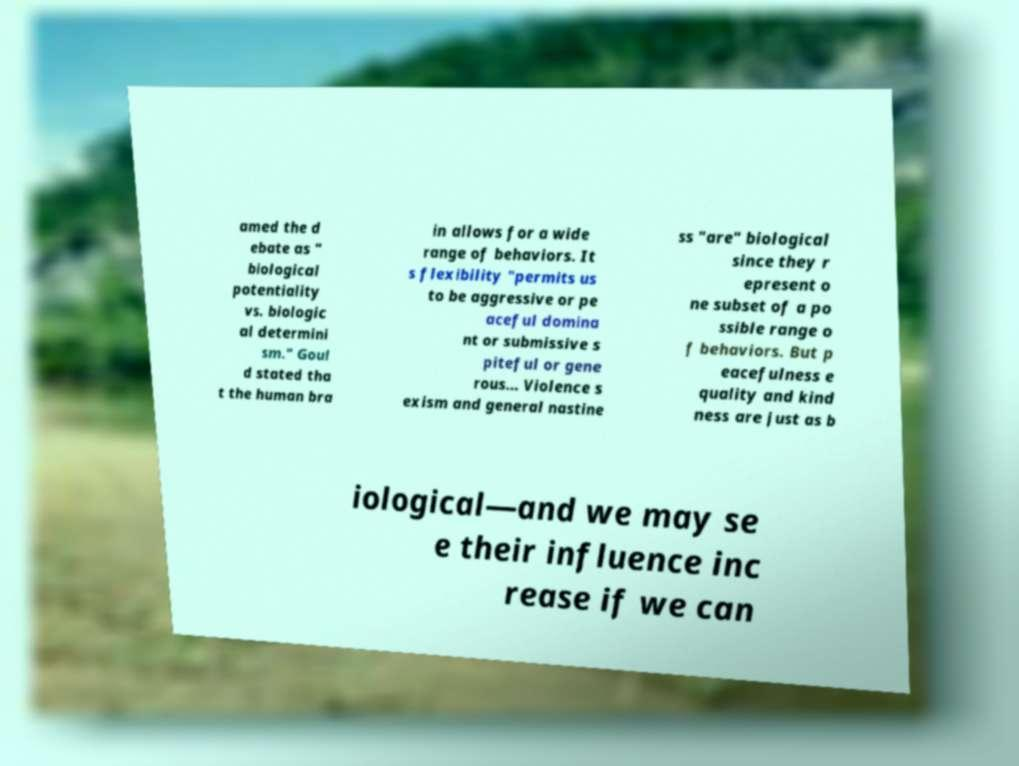I need the written content from this picture converted into text. Can you do that? amed the d ebate as " biological potentiality vs. biologic al determini sm." Goul d stated tha t the human bra in allows for a wide range of behaviors. It s flexibility "permits us to be aggressive or pe aceful domina nt or submissive s piteful or gene rous… Violence s exism and general nastine ss "are" biological since they r epresent o ne subset of a po ssible range o f behaviors. But p eacefulness e quality and kind ness are just as b iological—and we may se e their influence inc rease if we can 